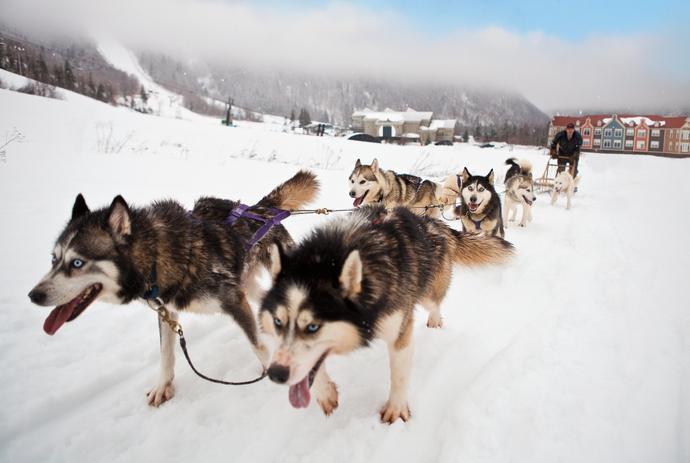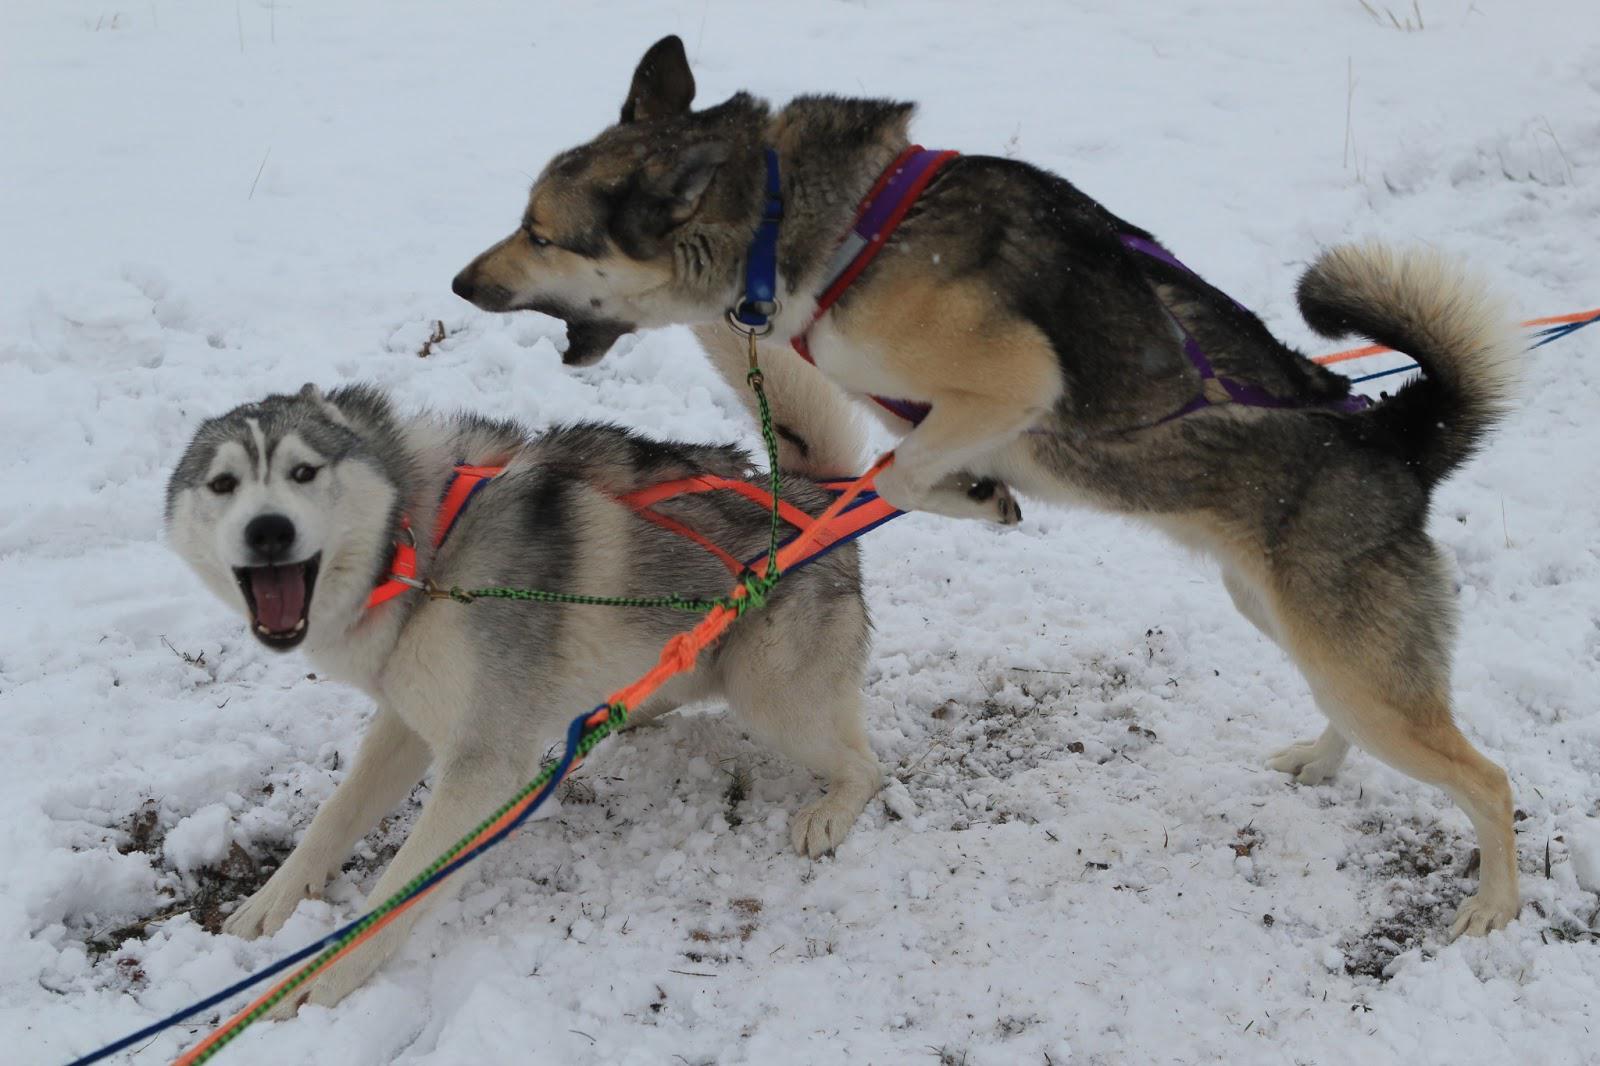The first image is the image on the left, the second image is the image on the right. Analyze the images presented: Is the assertion "The left image contains no more than two sled dogs." valid? Answer yes or no. No. The first image is the image on the left, the second image is the image on the right. Given the left and right images, does the statement "Two dogs are connected to reins in the image on the left." hold true? Answer yes or no. No. 